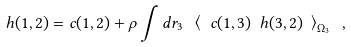<formula> <loc_0><loc_0><loc_500><loc_500>h ( 1 , 2 ) = c ( 1 , 2 ) + \rho \int d r _ { 3 } \ \left \langle \ c ( 1 , 3 ) \ h ( 3 , 2 ) \ \right \rangle _ { \Omega _ { 3 } } \ ,</formula> 